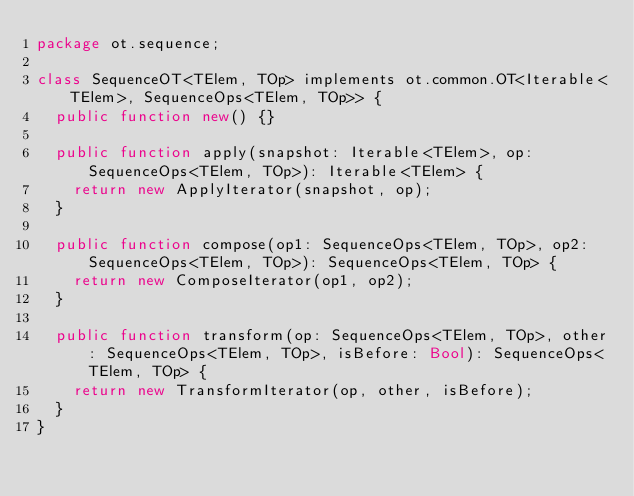<code> <loc_0><loc_0><loc_500><loc_500><_Haxe_>package ot.sequence;

class SequenceOT<TElem, TOp> implements ot.common.OT<Iterable<TElem>, SequenceOps<TElem, TOp>> {
  public function new() {}

  public function apply(snapshot: Iterable<TElem>, op: SequenceOps<TElem, TOp>): Iterable<TElem> {
    return new ApplyIterator(snapshot, op);
  }

  public function compose(op1: SequenceOps<TElem, TOp>, op2: SequenceOps<TElem, TOp>): SequenceOps<TElem, TOp> {
    return new ComposeIterator(op1, op2);
  }

  public function transform(op: SequenceOps<TElem, TOp>, other: SequenceOps<TElem, TOp>, isBefore: Bool): SequenceOps<TElem, TOp> {
    return new TransformIterator(op, other, isBefore);
  }
}
</code> 